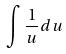Convert formula to latex. <formula><loc_0><loc_0><loc_500><loc_500>\int \frac { 1 } { u } d u</formula> 